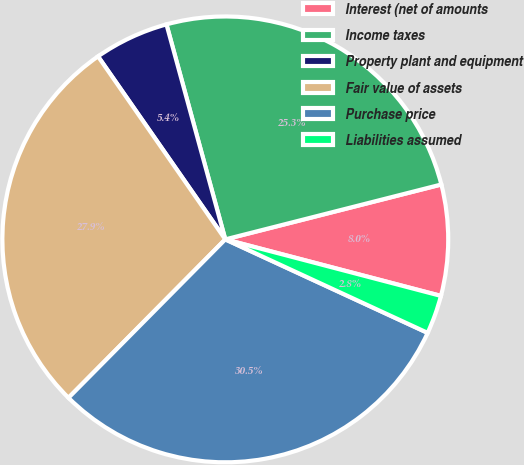Convert chart to OTSL. <chart><loc_0><loc_0><loc_500><loc_500><pie_chart><fcel>Interest (net of amounts<fcel>Income taxes<fcel>Property plant and equipment<fcel>Fair value of assets<fcel>Purchase price<fcel>Liabilities assumed<nl><fcel>8.04%<fcel>25.29%<fcel>5.42%<fcel>27.91%<fcel>30.53%<fcel>2.81%<nl></chart> 